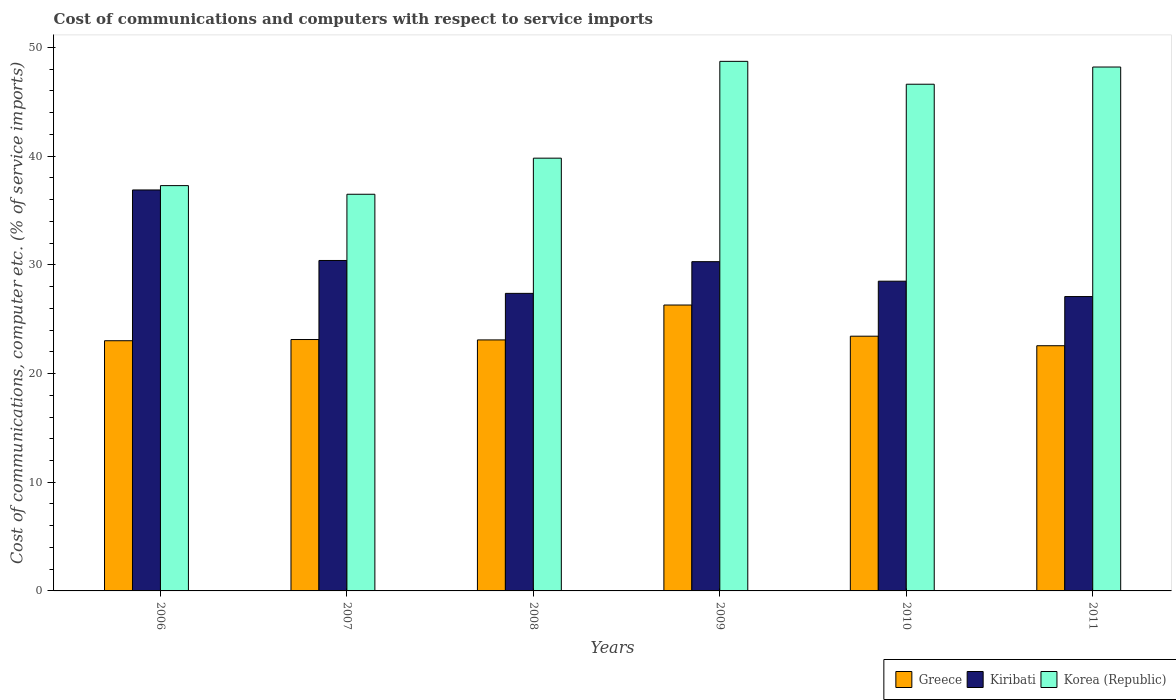How many groups of bars are there?
Offer a terse response. 6. Are the number of bars on each tick of the X-axis equal?
Make the answer very short. Yes. How many bars are there on the 4th tick from the right?
Offer a terse response. 3. What is the label of the 6th group of bars from the left?
Provide a succinct answer. 2011. What is the cost of communications and computers in Greece in 2007?
Provide a short and direct response. 23.13. Across all years, what is the maximum cost of communications and computers in Korea (Republic)?
Keep it short and to the point. 48.72. Across all years, what is the minimum cost of communications and computers in Kiribati?
Ensure brevity in your answer.  27.08. What is the total cost of communications and computers in Kiribati in the graph?
Keep it short and to the point. 180.54. What is the difference between the cost of communications and computers in Kiribati in 2009 and that in 2010?
Keep it short and to the point. 1.8. What is the difference between the cost of communications and computers in Greece in 2008 and the cost of communications and computers in Kiribati in 2010?
Keep it short and to the point. -5.4. What is the average cost of communications and computers in Korea (Republic) per year?
Give a very brief answer. 42.86. In the year 2010, what is the difference between the cost of communications and computers in Greece and cost of communications and computers in Korea (Republic)?
Make the answer very short. -23.18. In how many years, is the cost of communications and computers in Korea (Republic) greater than 22 %?
Keep it short and to the point. 6. What is the ratio of the cost of communications and computers in Korea (Republic) in 2006 to that in 2011?
Offer a very short reply. 0.77. Is the cost of communications and computers in Kiribati in 2007 less than that in 2011?
Your answer should be very brief. No. What is the difference between the highest and the second highest cost of communications and computers in Greece?
Your response must be concise. 2.87. What is the difference between the highest and the lowest cost of communications and computers in Kiribati?
Offer a terse response. 9.81. Is the sum of the cost of communications and computers in Kiribati in 2006 and 2008 greater than the maximum cost of communications and computers in Korea (Republic) across all years?
Ensure brevity in your answer.  Yes. What does the 2nd bar from the left in 2008 represents?
Offer a very short reply. Kiribati. What is the difference between two consecutive major ticks on the Y-axis?
Your response must be concise. 10. Does the graph contain any zero values?
Keep it short and to the point. No. What is the title of the graph?
Keep it short and to the point. Cost of communications and computers with respect to service imports. What is the label or title of the X-axis?
Keep it short and to the point. Years. What is the label or title of the Y-axis?
Provide a short and direct response. Cost of communications, computer etc. (% of service imports). What is the Cost of communications, computer etc. (% of service imports) in Greece in 2006?
Your response must be concise. 23.02. What is the Cost of communications, computer etc. (% of service imports) in Kiribati in 2006?
Keep it short and to the point. 36.89. What is the Cost of communications, computer etc. (% of service imports) of Korea (Republic) in 2006?
Your response must be concise. 37.29. What is the Cost of communications, computer etc. (% of service imports) in Greece in 2007?
Give a very brief answer. 23.13. What is the Cost of communications, computer etc. (% of service imports) in Kiribati in 2007?
Ensure brevity in your answer.  30.4. What is the Cost of communications, computer etc. (% of service imports) in Korea (Republic) in 2007?
Give a very brief answer. 36.49. What is the Cost of communications, computer etc. (% of service imports) in Greece in 2008?
Make the answer very short. 23.09. What is the Cost of communications, computer etc. (% of service imports) of Kiribati in 2008?
Provide a short and direct response. 27.38. What is the Cost of communications, computer etc. (% of service imports) of Korea (Republic) in 2008?
Your response must be concise. 39.81. What is the Cost of communications, computer etc. (% of service imports) in Greece in 2009?
Your answer should be compact. 26.3. What is the Cost of communications, computer etc. (% of service imports) in Kiribati in 2009?
Offer a terse response. 30.29. What is the Cost of communications, computer etc. (% of service imports) of Korea (Republic) in 2009?
Provide a succinct answer. 48.72. What is the Cost of communications, computer etc. (% of service imports) in Greece in 2010?
Offer a terse response. 23.44. What is the Cost of communications, computer etc. (% of service imports) in Kiribati in 2010?
Offer a very short reply. 28.5. What is the Cost of communications, computer etc. (% of service imports) in Korea (Republic) in 2010?
Your response must be concise. 46.62. What is the Cost of communications, computer etc. (% of service imports) of Greece in 2011?
Your answer should be very brief. 22.56. What is the Cost of communications, computer etc. (% of service imports) in Kiribati in 2011?
Your answer should be compact. 27.08. What is the Cost of communications, computer etc. (% of service imports) of Korea (Republic) in 2011?
Keep it short and to the point. 48.2. Across all years, what is the maximum Cost of communications, computer etc. (% of service imports) of Greece?
Keep it short and to the point. 26.3. Across all years, what is the maximum Cost of communications, computer etc. (% of service imports) of Kiribati?
Ensure brevity in your answer.  36.89. Across all years, what is the maximum Cost of communications, computer etc. (% of service imports) in Korea (Republic)?
Give a very brief answer. 48.72. Across all years, what is the minimum Cost of communications, computer etc. (% of service imports) of Greece?
Make the answer very short. 22.56. Across all years, what is the minimum Cost of communications, computer etc. (% of service imports) of Kiribati?
Ensure brevity in your answer.  27.08. Across all years, what is the minimum Cost of communications, computer etc. (% of service imports) of Korea (Republic)?
Give a very brief answer. 36.49. What is the total Cost of communications, computer etc. (% of service imports) of Greece in the graph?
Provide a succinct answer. 141.54. What is the total Cost of communications, computer etc. (% of service imports) of Kiribati in the graph?
Give a very brief answer. 180.54. What is the total Cost of communications, computer etc. (% of service imports) in Korea (Republic) in the graph?
Make the answer very short. 257.13. What is the difference between the Cost of communications, computer etc. (% of service imports) of Greece in 2006 and that in 2007?
Keep it short and to the point. -0.11. What is the difference between the Cost of communications, computer etc. (% of service imports) in Kiribati in 2006 and that in 2007?
Make the answer very short. 6.49. What is the difference between the Cost of communications, computer etc. (% of service imports) in Korea (Republic) in 2006 and that in 2007?
Give a very brief answer. 0.8. What is the difference between the Cost of communications, computer etc. (% of service imports) of Greece in 2006 and that in 2008?
Ensure brevity in your answer.  -0.08. What is the difference between the Cost of communications, computer etc. (% of service imports) of Kiribati in 2006 and that in 2008?
Your response must be concise. 9.51. What is the difference between the Cost of communications, computer etc. (% of service imports) in Korea (Republic) in 2006 and that in 2008?
Ensure brevity in your answer.  -2.53. What is the difference between the Cost of communications, computer etc. (% of service imports) of Greece in 2006 and that in 2009?
Give a very brief answer. -3.28. What is the difference between the Cost of communications, computer etc. (% of service imports) in Kiribati in 2006 and that in 2009?
Offer a terse response. 6.6. What is the difference between the Cost of communications, computer etc. (% of service imports) of Korea (Republic) in 2006 and that in 2009?
Offer a terse response. -11.43. What is the difference between the Cost of communications, computer etc. (% of service imports) of Greece in 2006 and that in 2010?
Your answer should be compact. -0.42. What is the difference between the Cost of communications, computer etc. (% of service imports) of Kiribati in 2006 and that in 2010?
Give a very brief answer. 8.39. What is the difference between the Cost of communications, computer etc. (% of service imports) of Korea (Republic) in 2006 and that in 2010?
Offer a terse response. -9.33. What is the difference between the Cost of communications, computer etc. (% of service imports) of Greece in 2006 and that in 2011?
Ensure brevity in your answer.  0.46. What is the difference between the Cost of communications, computer etc. (% of service imports) of Kiribati in 2006 and that in 2011?
Your answer should be very brief. 9.81. What is the difference between the Cost of communications, computer etc. (% of service imports) in Korea (Republic) in 2006 and that in 2011?
Make the answer very short. -10.91. What is the difference between the Cost of communications, computer etc. (% of service imports) of Greece in 2007 and that in 2008?
Keep it short and to the point. 0.04. What is the difference between the Cost of communications, computer etc. (% of service imports) of Kiribati in 2007 and that in 2008?
Your answer should be very brief. 3.03. What is the difference between the Cost of communications, computer etc. (% of service imports) of Korea (Republic) in 2007 and that in 2008?
Provide a short and direct response. -3.32. What is the difference between the Cost of communications, computer etc. (% of service imports) of Greece in 2007 and that in 2009?
Keep it short and to the point. -3.17. What is the difference between the Cost of communications, computer etc. (% of service imports) of Kiribati in 2007 and that in 2009?
Your answer should be very brief. 0.11. What is the difference between the Cost of communications, computer etc. (% of service imports) of Korea (Republic) in 2007 and that in 2009?
Provide a succinct answer. -12.23. What is the difference between the Cost of communications, computer etc. (% of service imports) in Greece in 2007 and that in 2010?
Ensure brevity in your answer.  -0.31. What is the difference between the Cost of communications, computer etc. (% of service imports) of Kiribati in 2007 and that in 2010?
Your response must be concise. 1.91. What is the difference between the Cost of communications, computer etc. (% of service imports) in Korea (Republic) in 2007 and that in 2010?
Your answer should be very brief. -10.12. What is the difference between the Cost of communications, computer etc. (% of service imports) of Greece in 2007 and that in 2011?
Offer a terse response. 0.57. What is the difference between the Cost of communications, computer etc. (% of service imports) of Kiribati in 2007 and that in 2011?
Offer a terse response. 3.32. What is the difference between the Cost of communications, computer etc. (% of service imports) in Korea (Republic) in 2007 and that in 2011?
Ensure brevity in your answer.  -11.71. What is the difference between the Cost of communications, computer etc. (% of service imports) of Greece in 2008 and that in 2009?
Offer a very short reply. -3.21. What is the difference between the Cost of communications, computer etc. (% of service imports) in Kiribati in 2008 and that in 2009?
Offer a terse response. -2.92. What is the difference between the Cost of communications, computer etc. (% of service imports) in Korea (Republic) in 2008 and that in 2009?
Your answer should be compact. -8.91. What is the difference between the Cost of communications, computer etc. (% of service imports) in Greece in 2008 and that in 2010?
Make the answer very short. -0.34. What is the difference between the Cost of communications, computer etc. (% of service imports) of Kiribati in 2008 and that in 2010?
Ensure brevity in your answer.  -1.12. What is the difference between the Cost of communications, computer etc. (% of service imports) of Korea (Republic) in 2008 and that in 2010?
Provide a short and direct response. -6.8. What is the difference between the Cost of communications, computer etc. (% of service imports) of Greece in 2008 and that in 2011?
Provide a succinct answer. 0.53. What is the difference between the Cost of communications, computer etc. (% of service imports) in Kiribati in 2008 and that in 2011?
Your answer should be compact. 0.29. What is the difference between the Cost of communications, computer etc. (% of service imports) in Korea (Republic) in 2008 and that in 2011?
Provide a short and direct response. -8.39. What is the difference between the Cost of communications, computer etc. (% of service imports) in Greece in 2009 and that in 2010?
Give a very brief answer. 2.87. What is the difference between the Cost of communications, computer etc. (% of service imports) in Kiribati in 2009 and that in 2010?
Offer a terse response. 1.8. What is the difference between the Cost of communications, computer etc. (% of service imports) in Korea (Republic) in 2009 and that in 2010?
Offer a very short reply. 2.1. What is the difference between the Cost of communications, computer etc. (% of service imports) in Greece in 2009 and that in 2011?
Provide a short and direct response. 3.74. What is the difference between the Cost of communications, computer etc. (% of service imports) of Kiribati in 2009 and that in 2011?
Offer a terse response. 3.21. What is the difference between the Cost of communications, computer etc. (% of service imports) of Korea (Republic) in 2009 and that in 2011?
Provide a succinct answer. 0.52. What is the difference between the Cost of communications, computer etc. (% of service imports) in Greece in 2010 and that in 2011?
Give a very brief answer. 0.88. What is the difference between the Cost of communications, computer etc. (% of service imports) in Kiribati in 2010 and that in 2011?
Your answer should be compact. 1.41. What is the difference between the Cost of communications, computer etc. (% of service imports) in Korea (Republic) in 2010 and that in 2011?
Your response must be concise. -1.58. What is the difference between the Cost of communications, computer etc. (% of service imports) of Greece in 2006 and the Cost of communications, computer etc. (% of service imports) of Kiribati in 2007?
Offer a terse response. -7.38. What is the difference between the Cost of communications, computer etc. (% of service imports) in Greece in 2006 and the Cost of communications, computer etc. (% of service imports) in Korea (Republic) in 2007?
Your answer should be compact. -13.48. What is the difference between the Cost of communications, computer etc. (% of service imports) in Kiribati in 2006 and the Cost of communications, computer etc. (% of service imports) in Korea (Republic) in 2007?
Make the answer very short. 0.4. What is the difference between the Cost of communications, computer etc. (% of service imports) in Greece in 2006 and the Cost of communications, computer etc. (% of service imports) in Kiribati in 2008?
Make the answer very short. -4.36. What is the difference between the Cost of communications, computer etc. (% of service imports) of Greece in 2006 and the Cost of communications, computer etc. (% of service imports) of Korea (Republic) in 2008?
Provide a succinct answer. -16.8. What is the difference between the Cost of communications, computer etc. (% of service imports) in Kiribati in 2006 and the Cost of communications, computer etc. (% of service imports) in Korea (Republic) in 2008?
Your response must be concise. -2.93. What is the difference between the Cost of communications, computer etc. (% of service imports) in Greece in 2006 and the Cost of communications, computer etc. (% of service imports) in Kiribati in 2009?
Offer a terse response. -7.28. What is the difference between the Cost of communications, computer etc. (% of service imports) in Greece in 2006 and the Cost of communications, computer etc. (% of service imports) in Korea (Republic) in 2009?
Provide a succinct answer. -25.7. What is the difference between the Cost of communications, computer etc. (% of service imports) in Kiribati in 2006 and the Cost of communications, computer etc. (% of service imports) in Korea (Republic) in 2009?
Your response must be concise. -11.83. What is the difference between the Cost of communications, computer etc. (% of service imports) of Greece in 2006 and the Cost of communications, computer etc. (% of service imports) of Kiribati in 2010?
Provide a short and direct response. -5.48. What is the difference between the Cost of communications, computer etc. (% of service imports) in Greece in 2006 and the Cost of communications, computer etc. (% of service imports) in Korea (Republic) in 2010?
Make the answer very short. -23.6. What is the difference between the Cost of communications, computer etc. (% of service imports) in Kiribati in 2006 and the Cost of communications, computer etc. (% of service imports) in Korea (Republic) in 2010?
Offer a very short reply. -9.73. What is the difference between the Cost of communications, computer etc. (% of service imports) of Greece in 2006 and the Cost of communications, computer etc. (% of service imports) of Kiribati in 2011?
Ensure brevity in your answer.  -4.06. What is the difference between the Cost of communications, computer etc. (% of service imports) in Greece in 2006 and the Cost of communications, computer etc. (% of service imports) in Korea (Republic) in 2011?
Your answer should be compact. -25.18. What is the difference between the Cost of communications, computer etc. (% of service imports) in Kiribati in 2006 and the Cost of communications, computer etc. (% of service imports) in Korea (Republic) in 2011?
Ensure brevity in your answer.  -11.31. What is the difference between the Cost of communications, computer etc. (% of service imports) of Greece in 2007 and the Cost of communications, computer etc. (% of service imports) of Kiribati in 2008?
Give a very brief answer. -4.25. What is the difference between the Cost of communications, computer etc. (% of service imports) of Greece in 2007 and the Cost of communications, computer etc. (% of service imports) of Korea (Republic) in 2008?
Your response must be concise. -16.69. What is the difference between the Cost of communications, computer etc. (% of service imports) of Kiribati in 2007 and the Cost of communications, computer etc. (% of service imports) of Korea (Republic) in 2008?
Offer a terse response. -9.41. What is the difference between the Cost of communications, computer etc. (% of service imports) of Greece in 2007 and the Cost of communications, computer etc. (% of service imports) of Kiribati in 2009?
Your answer should be compact. -7.16. What is the difference between the Cost of communications, computer etc. (% of service imports) in Greece in 2007 and the Cost of communications, computer etc. (% of service imports) in Korea (Republic) in 2009?
Offer a terse response. -25.59. What is the difference between the Cost of communications, computer etc. (% of service imports) of Kiribati in 2007 and the Cost of communications, computer etc. (% of service imports) of Korea (Republic) in 2009?
Offer a terse response. -18.32. What is the difference between the Cost of communications, computer etc. (% of service imports) in Greece in 2007 and the Cost of communications, computer etc. (% of service imports) in Kiribati in 2010?
Your response must be concise. -5.37. What is the difference between the Cost of communications, computer etc. (% of service imports) of Greece in 2007 and the Cost of communications, computer etc. (% of service imports) of Korea (Republic) in 2010?
Keep it short and to the point. -23.49. What is the difference between the Cost of communications, computer etc. (% of service imports) of Kiribati in 2007 and the Cost of communications, computer etc. (% of service imports) of Korea (Republic) in 2010?
Provide a succinct answer. -16.21. What is the difference between the Cost of communications, computer etc. (% of service imports) of Greece in 2007 and the Cost of communications, computer etc. (% of service imports) of Kiribati in 2011?
Offer a terse response. -3.95. What is the difference between the Cost of communications, computer etc. (% of service imports) in Greece in 2007 and the Cost of communications, computer etc. (% of service imports) in Korea (Republic) in 2011?
Provide a succinct answer. -25.07. What is the difference between the Cost of communications, computer etc. (% of service imports) in Kiribati in 2007 and the Cost of communications, computer etc. (% of service imports) in Korea (Republic) in 2011?
Offer a terse response. -17.8. What is the difference between the Cost of communications, computer etc. (% of service imports) in Greece in 2008 and the Cost of communications, computer etc. (% of service imports) in Kiribati in 2009?
Provide a short and direct response. -7.2. What is the difference between the Cost of communications, computer etc. (% of service imports) in Greece in 2008 and the Cost of communications, computer etc. (% of service imports) in Korea (Republic) in 2009?
Your response must be concise. -25.63. What is the difference between the Cost of communications, computer etc. (% of service imports) in Kiribati in 2008 and the Cost of communications, computer etc. (% of service imports) in Korea (Republic) in 2009?
Keep it short and to the point. -21.35. What is the difference between the Cost of communications, computer etc. (% of service imports) of Greece in 2008 and the Cost of communications, computer etc. (% of service imports) of Kiribati in 2010?
Your answer should be very brief. -5.4. What is the difference between the Cost of communications, computer etc. (% of service imports) in Greece in 2008 and the Cost of communications, computer etc. (% of service imports) in Korea (Republic) in 2010?
Your response must be concise. -23.52. What is the difference between the Cost of communications, computer etc. (% of service imports) of Kiribati in 2008 and the Cost of communications, computer etc. (% of service imports) of Korea (Republic) in 2010?
Your answer should be very brief. -19.24. What is the difference between the Cost of communications, computer etc. (% of service imports) of Greece in 2008 and the Cost of communications, computer etc. (% of service imports) of Kiribati in 2011?
Ensure brevity in your answer.  -3.99. What is the difference between the Cost of communications, computer etc. (% of service imports) in Greece in 2008 and the Cost of communications, computer etc. (% of service imports) in Korea (Republic) in 2011?
Provide a succinct answer. -25.11. What is the difference between the Cost of communications, computer etc. (% of service imports) of Kiribati in 2008 and the Cost of communications, computer etc. (% of service imports) of Korea (Republic) in 2011?
Your response must be concise. -20.82. What is the difference between the Cost of communications, computer etc. (% of service imports) in Greece in 2009 and the Cost of communications, computer etc. (% of service imports) in Kiribati in 2010?
Your answer should be very brief. -2.19. What is the difference between the Cost of communications, computer etc. (% of service imports) of Greece in 2009 and the Cost of communications, computer etc. (% of service imports) of Korea (Republic) in 2010?
Give a very brief answer. -20.31. What is the difference between the Cost of communications, computer etc. (% of service imports) in Kiribati in 2009 and the Cost of communications, computer etc. (% of service imports) in Korea (Republic) in 2010?
Ensure brevity in your answer.  -16.32. What is the difference between the Cost of communications, computer etc. (% of service imports) of Greece in 2009 and the Cost of communications, computer etc. (% of service imports) of Kiribati in 2011?
Keep it short and to the point. -0.78. What is the difference between the Cost of communications, computer etc. (% of service imports) of Greece in 2009 and the Cost of communications, computer etc. (% of service imports) of Korea (Republic) in 2011?
Offer a very short reply. -21.9. What is the difference between the Cost of communications, computer etc. (% of service imports) of Kiribati in 2009 and the Cost of communications, computer etc. (% of service imports) of Korea (Republic) in 2011?
Make the answer very short. -17.91. What is the difference between the Cost of communications, computer etc. (% of service imports) of Greece in 2010 and the Cost of communications, computer etc. (% of service imports) of Kiribati in 2011?
Give a very brief answer. -3.65. What is the difference between the Cost of communications, computer etc. (% of service imports) in Greece in 2010 and the Cost of communications, computer etc. (% of service imports) in Korea (Republic) in 2011?
Your answer should be compact. -24.77. What is the difference between the Cost of communications, computer etc. (% of service imports) in Kiribati in 2010 and the Cost of communications, computer etc. (% of service imports) in Korea (Republic) in 2011?
Provide a short and direct response. -19.7. What is the average Cost of communications, computer etc. (% of service imports) in Greece per year?
Make the answer very short. 23.59. What is the average Cost of communications, computer etc. (% of service imports) in Kiribati per year?
Offer a very short reply. 30.09. What is the average Cost of communications, computer etc. (% of service imports) of Korea (Republic) per year?
Offer a terse response. 42.86. In the year 2006, what is the difference between the Cost of communications, computer etc. (% of service imports) of Greece and Cost of communications, computer etc. (% of service imports) of Kiribati?
Your answer should be very brief. -13.87. In the year 2006, what is the difference between the Cost of communications, computer etc. (% of service imports) of Greece and Cost of communications, computer etc. (% of service imports) of Korea (Republic)?
Keep it short and to the point. -14.27. In the year 2006, what is the difference between the Cost of communications, computer etc. (% of service imports) in Kiribati and Cost of communications, computer etc. (% of service imports) in Korea (Republic)?
Provide a succinct answer. -0.4. In the year 2007, what is the difference between the Cost of communications, computer etc. (% of service imports) in Greece and Cost of communications, computer etc. (% of service imports) in Kiribati?
Your response must be concise. -7.27. In the year 2007, what is the difference between the Cost of communications, computer etc. (% of service imports) in Greece and Cost of communications, computer etc. (% of service imports) in Korea (Republic)?
Provide a short and direct response. -13.36. In the year 2007, what is the difference between the Cost of communications, computer etc. (% of service imports) in Kiribati and Cost of communications, computer etc. (% of service imports) in Korea (Republic)?
Keep it short and to the point. -6.09. In the year 2008, what is the difference between the Cost of communications, computer etc. (% of service imports) in Greece and Cost of communications, computer etc. (% of service imports) in Kiribati?
Make the answer very short. -4.28. In the year 2008, what is the difference between the Cost of communications, computer etc. (% of service imports) of Greece and Cost of communications, computer etc. (% of service imports) of Korea (Republic)?
Your answer should be compact. -16.72. In the year 2008, what is the difference between the Cost of communications, computer etc. (% of service imports) of Kiribati and Cost of communications, computer etc. (% of service imports) of Korea (Republic)?
Provide a short and direct response. -12.44. In the year 2009, what is the difference between the Cost of communications, computer etc. (% of service imports) in Greece and Cost of communications, computer etc. (% of service imports) in Kiribati?
Offer a terse response. -3.99. In the year 2009, what is the difference between the Cost of communications, computer etc. (% of service imports) of Greece and Cost of communications, computer etc. (% of service imports) of Korea (Republic)?
Your response must be concise. -22.42. In the year 2009, what is the difference between the Cost of communications, computer etc. (% of service imports) of Kiribati and Cost of communications, computer etc. (% of service imports) of Korea (Republic)?
Offer a terse response. -18.43. In the year 2010, what is the difference between the Cost of communications, computer etc. (% of service imports) of Greece and Cost of communications, computer etc. (% of service imports) of Kiribati?
Your response must be concise. -5.06. In the year 2010, what is the difference between the Cost of communications, computer etc. (% of service imports) in Greece and Cost of communications, computer etc. (% of service imports) in Korea (Republic)?
Offer a terse response. -23.18. In the year 2010, what is the difference between the Cost of communications, computer etc. (% of service imports) in Kiribati and Cost of communications, computer etc. (% of service imports) in Korea (Republic)?
Provide a succinct answer. -18.12. In the year 2011, what is the difference between the Cost of communications, computer etc. (% of service imports) of Greece and Cost of communications, computer etc. (% of service imports) of Kiribati?
Provide a short and direct response. -4.52. In the year 2011, what is the difference between the Cost of communications, computer etc. (% of service imports) of Greece and Cost of communications, computer etc. (% of service imports) of Korea (Republic)?
Provide a short and direct response. -25.64. In the year 2011, what is the difference between the Cost of communications, computer etc. (% of service imports) of Kiribati and Cost of communications, computer etc. (% of service imports) of Korea (Republic)?
Offer a very short reply. -21.12. What is the ratio of the Cost of communications, computer etc. (% of service imports) in Kiribati in 2006 to that in 2007?
Your answer should be compact. 1.21. What is the ratio of the Cost of communications, computer etc. (% of service imports) of Korea (Republic) in 2006 to that in 2007?
Provide a short and direct response. 1.02. What is the ratio of the Cost of communications, computer etc. (% of service imports) in Greece in 2006 to that in 2008?
Keep it short and to the point. 1. What is the ratio of the Cost of communications, computer etc. (% of service imports) of Kiribati in 2006 to that in 2008?
Your answer should be very brief. 1.35. What is the ratio of the Cost of communications, computer etc. (% of service imports) of Korea (Republic) in 2006 to that in 2008?
Provide a short and direct response. 0.94. What is the ratio of the Cost of communications, computer etc. (% of service imports) in Greece in 2006 to that in 2009?
Make the answer very short. 0.88. What is the ratio of the Cost of communications, computer etc. (% of service imports) of Kiribati in 2006 to that in 2009?
Give a very brief answer. 1.22. What is the ratio of the Cost of communications, computer etc. (% of service imports) in Korea (Republic) in 2006 to that in 2009?
Provide a short and direct response. 0.77. What is the ratio of the Cost of communications, computer etc. (% of service imports) in Greece in 2006 to that in 2010?
Provide a succinct answer. 0.98. What is the ratio of the Cost of communications, computer etc. (% of service imports) in Kiribati in 2006 to that in 2010?
Keep it short and to the point. 1.29. What is the ratio of the Cost of communications, computer etc. (% of service imports) of Korea (Republic) in 2006 to that in 2010?
Keep it short and to the point. 0.8. What is the ratio of the Cost of communications, computer etc. (% of service imports) in Greece in 2006 to that in 2011?
Offer a very short reply. 1.02. What is the ratio of the Cost of communications, computer etc. (% of service imports) of Kiribati in 2006 to that in 2011?
Offer a terse response. 1.36. What is the ratio of the Cost of communications, computer etc. (% of service imports) in Korea (Republic) in 2006 to that in 2011?
Provide a short and direct response. 0.77. What is the ratio of the Cost of communications, computer etc. (% of service imports) in Kiribati in 2007 to that in 2008?
Provide a succinct answer. 1.11. What is the ratio of the Cost of communications, computer etc. (% of service imports) in Korea (Republic) in 2007 to that in 2008?
Ensure brevity in your answer.  0.92. What is the ratio of the Cost of communications, computer etc. (% of service imports) of Greece in 2007 to that in 2009?
Offer a terse response. 0.88. What is the ratio of the Cost of communications, computer etc. (% of service imports) in Kiribati in 2007 to that in 2009?
Ensure brevity in your answer.  1. What is the ratio of the Cost of communications, computer etc. (% of service imports) in Korea (Republic) in 2007 to that in 2009?
Offer a terse response. 0.75. What is the ratio of the Cost of communications, computer etc. (% of service imports) in Greece in 2007 to that in 2010?
Offer a terse response. 0.99. What is the ratio of the Cost of communications, computer etc. (% of service imports) of Kiribati in 2007 to that in 2010?
Your answer should be compact. 1.07. What is the ratio of the Cost of communications, computer etc. (% of service imports) in Korea (Republic) in 2007 to that in 2010?
Offer a terse response. 0.78. What is the ratio of the Cost of communications, computer etc. (% of service imports) of Greece in 2007 to that in 2011?
Your answer should be compact. 1.03. What is the ratio of the Cost of communications, computer etc. (% of service imports) in Kiribati in 2007 to that in 2011?
Ensure brevity in your answer.  1.12. What is the ratio of the Cost of communications, computer etc. (% of service imports) of Korea (Republic) in 2007 to that in 2011?
Give a very brief answer. 0.76. What is the ratio of the Cost of communications, computer etc. (% of service imports) in Greece in 2008 to that in 2009?
Your answer should be compact. 0.88. What is the ratio of the Cost of communications, computer etc. (% of service imports) of Kiribati in 2008 to that in 2009?
Offer a terse response. 0.9. What is the ratio of the Cost of communications, computer etc. (% of service imports) of Korea (Republic) in 2008 to that in 2009?
Offer a terse response. 0.82. What is the ratio of the Cost of communications, computer etc. (% of service imports) in Greece in 2008 to that in 2010?
Your answer should be very brief. 0.99. What is the ratio of the Cost of communications, computer etc. (% of service imports) in Kiribati in 2008 to that in 2010?
Keep it short and to the point. 0.96. What is the ratio of the Cost of communications, computer etc. (% of service imports) of Korea (Republic) in 2008 to that in 2010?
Your answer should be very brief. 0.85. What is the ratio of the Cost of communications, computer etc. (% of service imports) in Greece in 2008 to that in 2011?
Your answer should be compact. 1.02. What is the ratio of the Cost of communications, computer etc. (% of service imports) in Kiribati in 2008 to that in 2011?
Give a very brief answer. 1.01. What is the ratio of the Cost of communications, computer etc. (% of service imports) of Korea (Republic) in 2008 to that in 2011?
Offer a very short reply. 0.83. What is the ratio of the Cost of communications, computer etc. (% of service imports) of Greece in 2009 to that in 2010?
Provide a short and direct response. 1.12. What is the ratio of the Cost of communications, computer etc. (% of service imports) of Kiribati in 2009 to that in 2010?
Your answer should be compact. 1.06. What is the ratio of the Cost of communications, computer etc. (% of service imports) of Korea (Republic) in 2009 to that in 2010?
Keep it short and to the point. 1.05. What is the ratio of the Cost of communications, computer etc. (% of service imports) in Greece in 2009 to that in 2011?
Offer a very short reply. 1.17. What is the ratio of the Cost of communications, computer etc. (% of service imports) in Kiribati in 2009 to that in 2011?
Your response must be concise. 1.12. What is the ratio of the Cost of communications, computer etc. (% of service imports) in Korea (Republic) in 2009 to that in 2011?
Offer a terse response. 1.01. What is the ratio of the Cost of communications, computer etc. (% of service imports) of Greece in 2010 to that in 2011?
Offer a terse response. 1.04. What is the ratio of the Cost of communications, computer etc. (% of service imports) of Kiribati in 2010 to that in 2011?
Make the answer very short. 1.05. What is the ratio of the Cost of communications, computer etc. (% of service imports) in Korea (Republic) in 2010 to that in 2011?
Offer a terse response. 0.97. What is the difference between the highest and the second highest Cost of communications, computer etc. (% of service imports) in Greece?
Keep it short and to the point. 2.87. What is the difference between the highest and the second highest Cost of communications, computer etc. (% of service imports) of Kiribati?
Give a very brief answer. 6.49. What is the difference between the highest and the second highest Cost of communications, computer etc. (% of service imports) of Korea (Republic)?
Provide a succinct answer. 0.52. What is the difference between the highest and the lowest Cost of communications, computer etc. (% of service imports) in Greece?
Provide a succinct answer. 3.74. What is the difference between the highest and the lowest Cost of communications, computer etc. (% of service imports) of Kiribati?
Provide a short and direct response. 9.81. What is the difference between the highest and the lowest Cost of communications, computer etc. (% of service imports) in Korea (Republic)?
Your answer should be very brief. 12.23. 